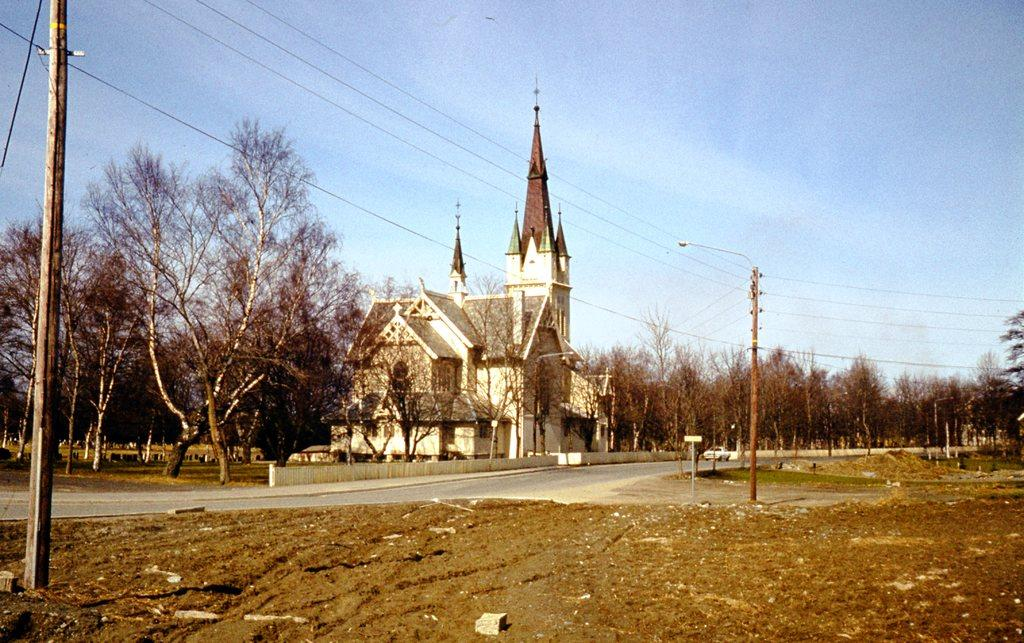What structures can be seen in the image? There are poles and a building visible in the image. What is connected to the poles in the image? Electric wires are present in the image. What is on the ground in the image? There are objects on the grass on the ground. What type of pathway is visible in the image? There is a road visible in the image. What can be seen in the background of the image? There are trees, poles, and a building in the background of the image. What is visible in the sky in the background of the image? Clouds are visible in the sky in the background of the image. What is the annual income of the flag in the image? There is no flag present in the image, so it is not possible to determine its annual income. 